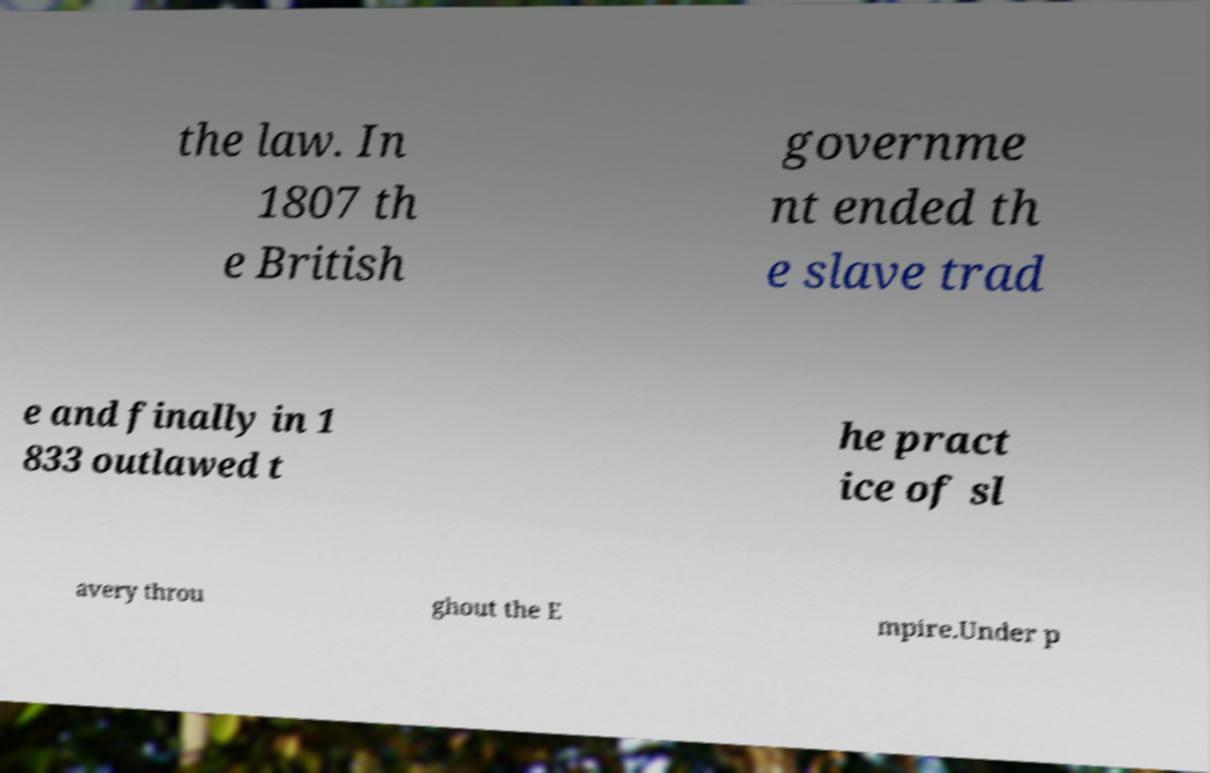For documentation purposes, I need the text within this image transcribed. Could you provide that? the law. In 1807 th e British governme nt ended th e slave trad e and finally in 1 833 outlawed t he pract ice of sl avery throu ghout the E mpire.Under p 